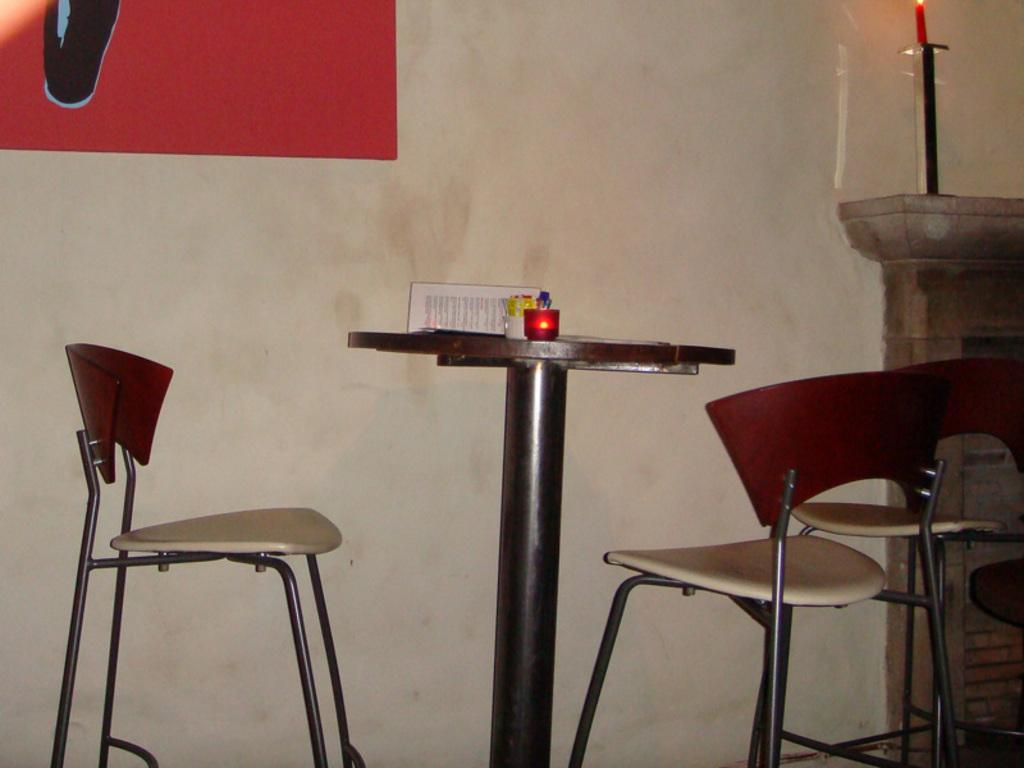What piece of furniture is in the image? There is a table in the image. What is placed on the table? There is a candle and a book on the table. How many chairs are in the image? There are 2 chairs in the image. Is there another candle visible in the image? Yes, there is a candle present at the back of the image. What type of button can be seen on the cracker in the image? There is no cracker or button present in the image. 